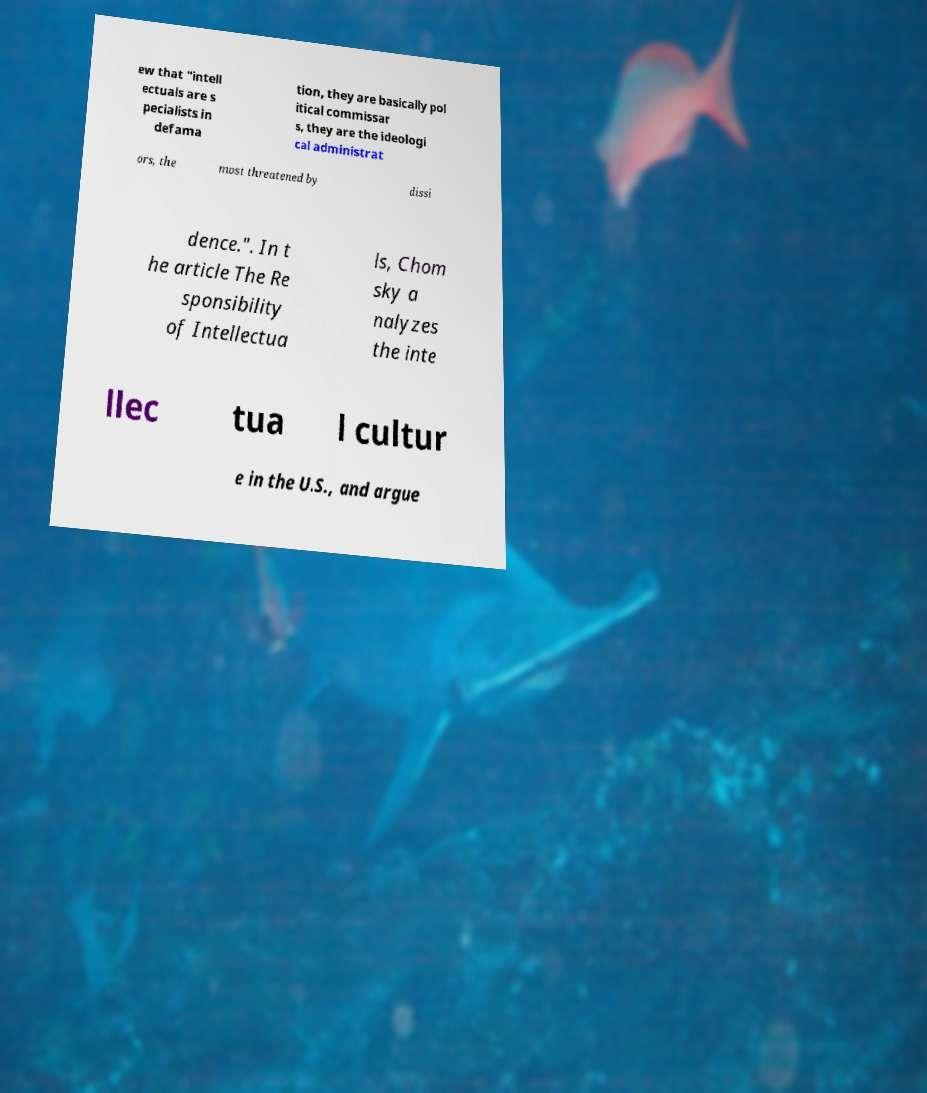Please identify and transcribe the text found in this image. ew that "intell ectuals are s pecialists in defama tion, they are basically pol itical commissar s, they are the ideologi cal administrat ors, the most threatened by dissi dence.". In t he article The Re sponsibility of Intellectua ls, Chom sky a nalyzes the inte llec tua l cultur e in the U.S., and argue 